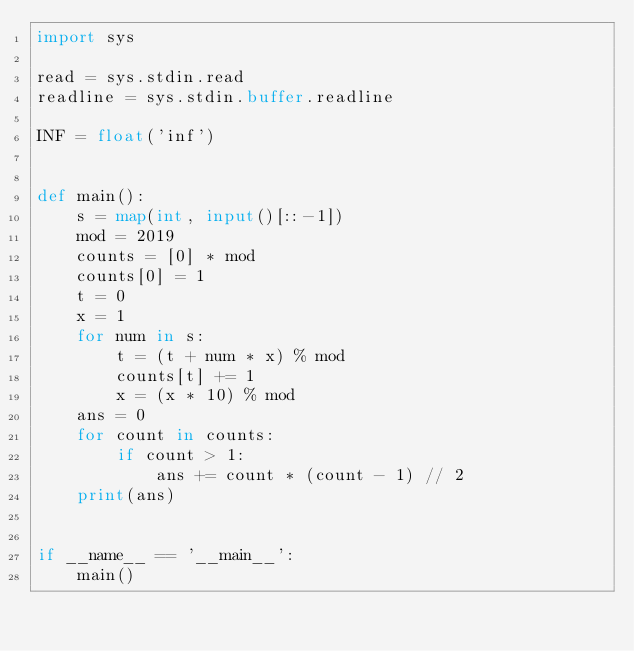Convert code to text. <code><loc_0><loc_0><loc_500><loc_500><_Python_>import sys

read = sys.stdin.read
readline = sys.stdin.buffer.readline

INF = float('inf')


def main():
    s = map(int, input()[::-1])
    mod = 2019
    counts = [0] * mod
    counts[0] = 1
    t = 0
    x = 1
    for num in s:
        t = (t + num * x) % mod
        counts[t] += 1
        x = (x * 10) % mod
    ans = 0
    for count in counts:
        if count > 1:
            ans += count * (count - 1) // 2
    print(ans)


if __name__ == '__main__':
    main()
</code> 